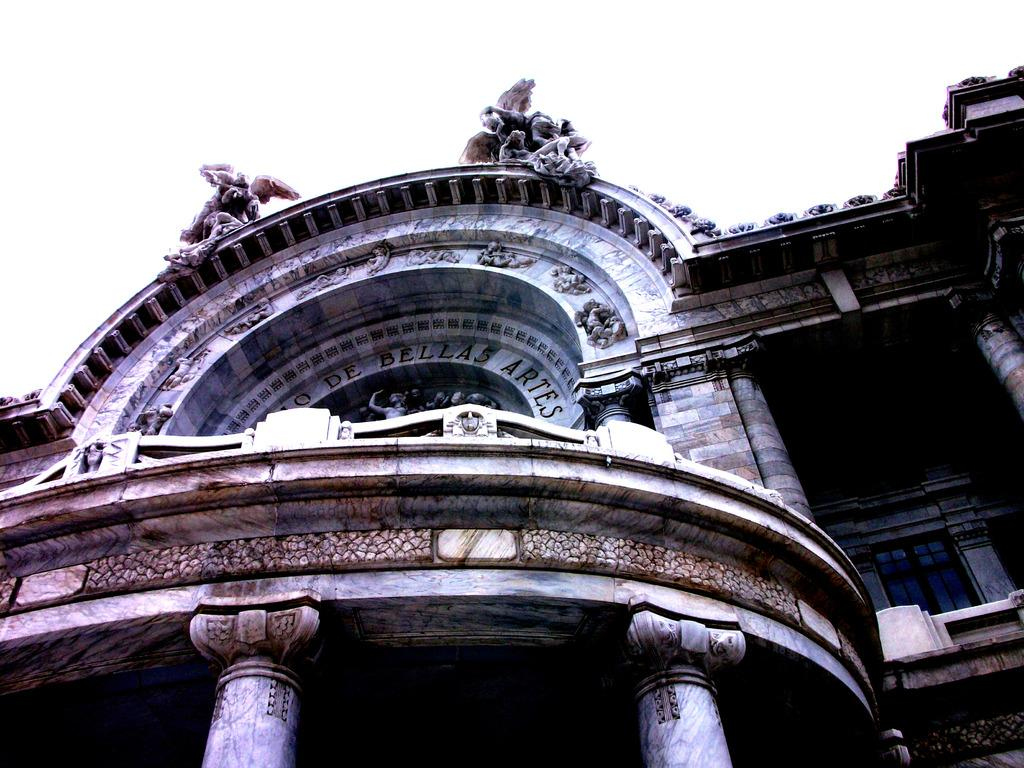What type of structure is visible in the image? There is a building in the image. What features can be seen on the building? The building has carvings and statues, as well as text and pillars. What color is present at the top of the image? The top of the image has a white color. Can you tell me how the approval process for the building was conducted in the image? There is no information about an approval process for the building in the image. Is there a lake visible in the image? No, there is no lake present in the image. 